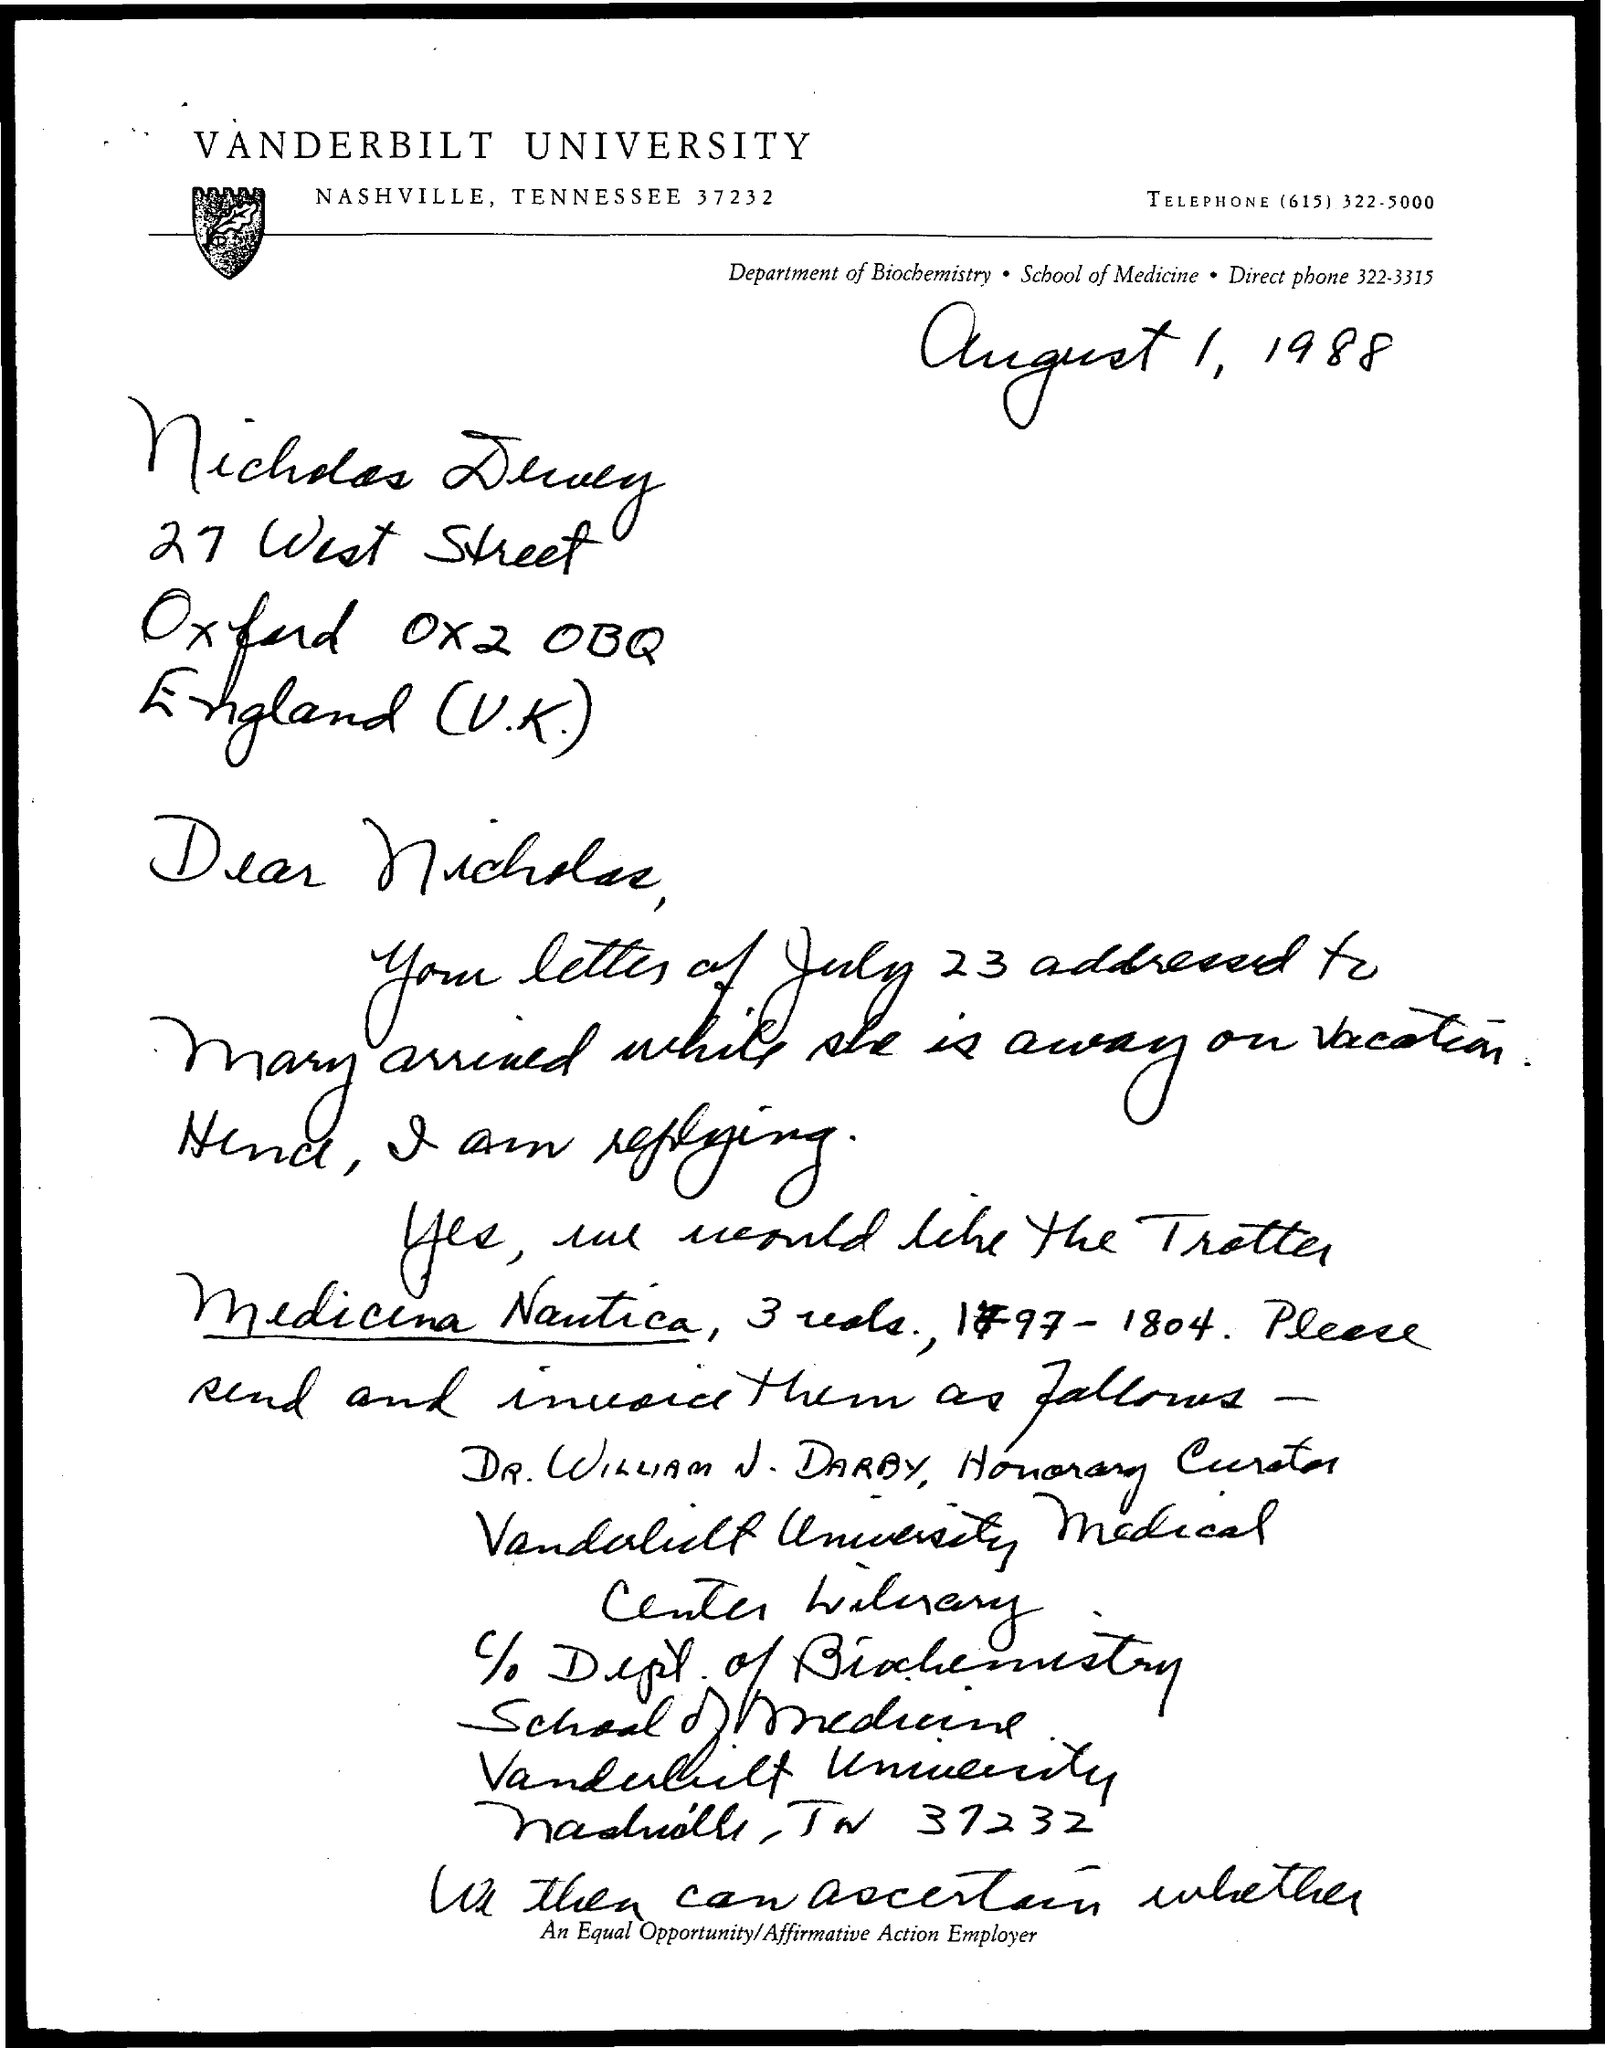Mention a couple of crucial points in this snapshot. The date mentioned in the document is August 1, 1988. Vanderbilt University is named. The telephone number is (615) 322-5000. 